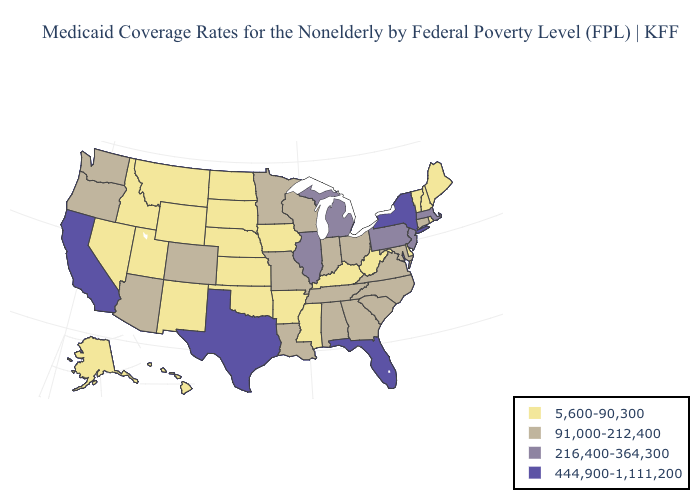What is the value of Maine?
Quick response, please. 5,600-90,300. Name the states that have a value in the range 444,900-1,111,200?
Give a very brief answer. California, Florida, New York, Texas. What is the highest value in the South ?
Answer briefly. 444,900-1,111,200. Name the states that have a value in the range 216,400-364,300?
Concise answer only. Illinois, Massachusetts, Michigan, New Jersey, Pennsylvania. Which states have the lowest value in the South?
Give a very brief answer. Arkansas, Delaware, Kentucky, Mississippi, Oklahoma, West Virginia. Which states have the highest value in the USA?
Keep it brief. California, Florida, New York, Texas. Among the states that border Connecticut , which have the highest value?
Keep it brief. New York. Name the states that have a value in the range 216,400-364,300?
Write a very short answer. Illinois, Massachusetts, Michigan, New Jersey, Pennsylvania. Does Colorado have the highest value in the USA?
Short answer required. No. Among the states that border Wisconsin , which have the highest value?
Keep it brief. Illinois, Michigan. Does California have the highest value in the West?
Give a very brief answer. Yes. Among the states that border Oklahoma , does Kansas have the highest value?
Keep it brief. No. What is the highest value in the South ?
Keep it brief. 444,900-1,111,200. Does Vermont have the same value as Oklahoma?
Concise answer only. Yes. Name the states that have a value in the range 5,600-90,300?
Concise answer only. Alaska, Arkansas, Delaware, Hawaii, Idaho, Iowa, Kansas, Kentucky, Maine, Mississippi, Montana, Nebraska, Nevada, New Hampshire, New Mexico, North Dakota, Oklahoma, Rhode Island, South Dakota, Utah, Vermont, West Virginia, Wyoming. 